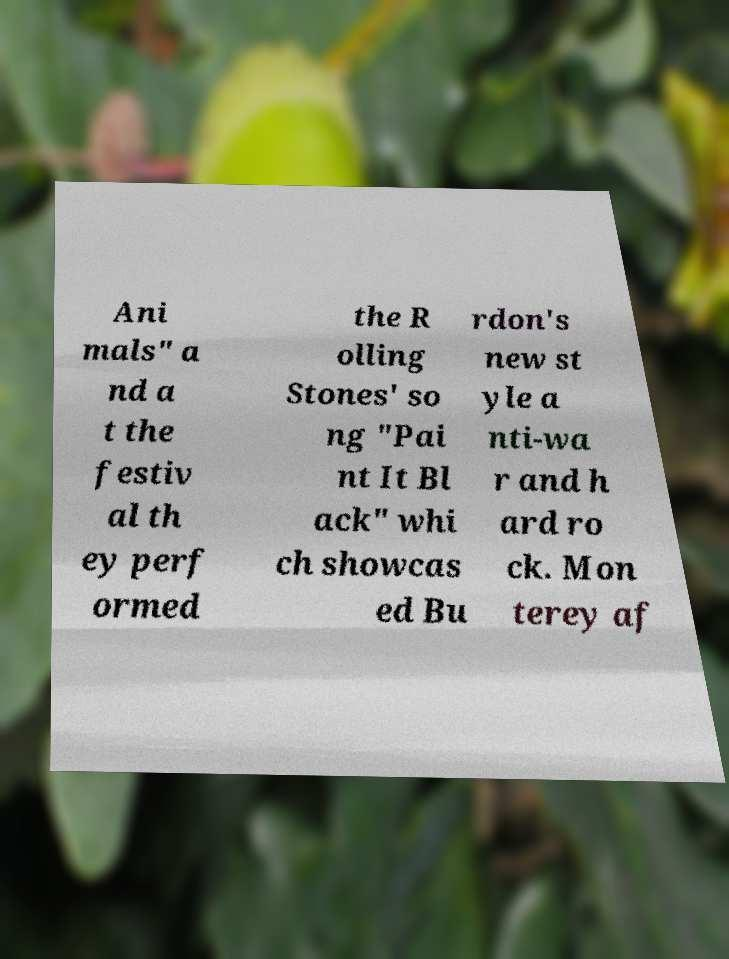For documentation purposes, I need the text within this image transcribed. Could you provide that? Ani mals" a nd a t the festiv al th ey perf ormed the R olling Stones' so ng "Pai nt It Bl ack" whi ch showcas ed Bu rdon's new st yle a nti-wa r and h ard ro ck. Mon terey af 